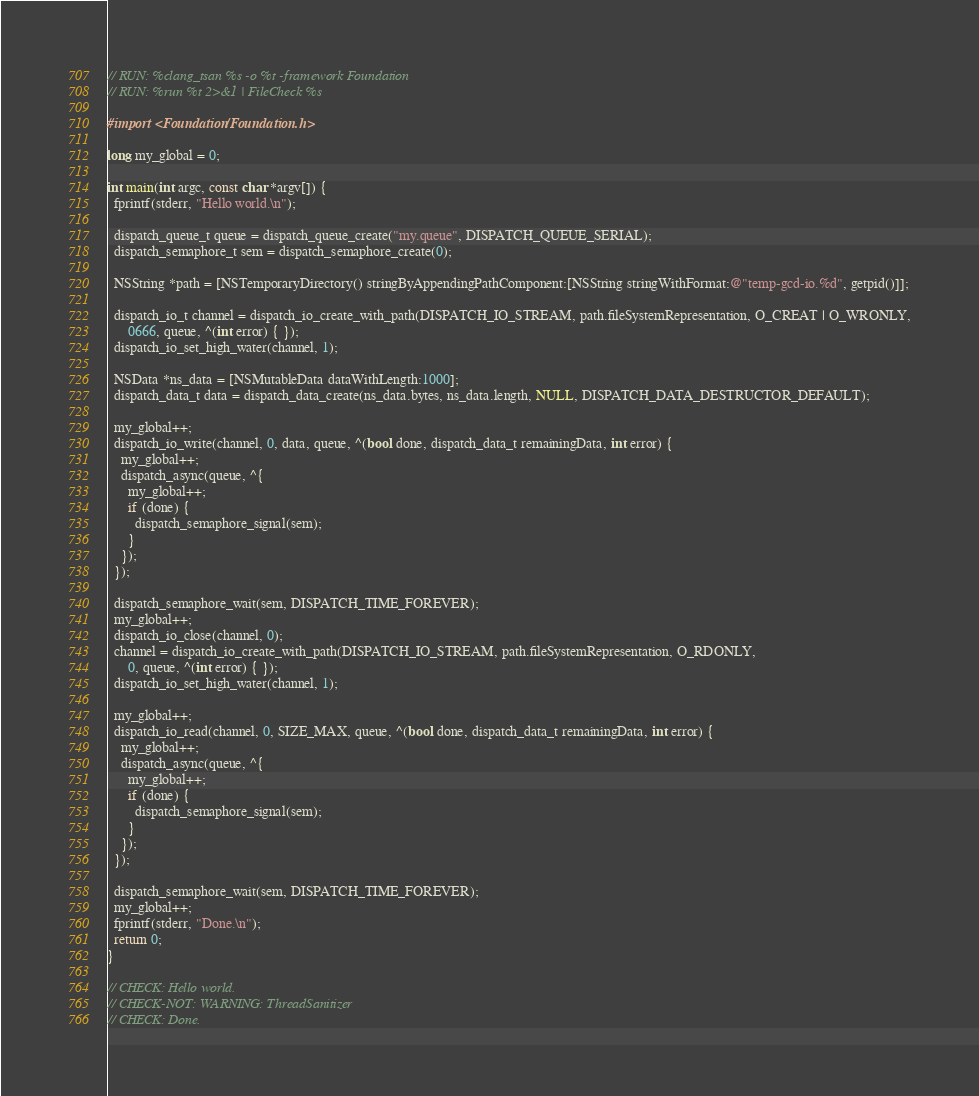<code> <loc_0><loc_0><loc_500><loc_500><_ObjectiveC_>// RUN: %clang_tsan %s -o %t -framework Foundation
// RUN: %run %t 2>&1 | FileCheck %s

#import <Foundation/Foundation.h>

long my_global = 0;

int main(int argc, const char *argv[]) {
  fprintf(stderr, "Hello world.\n");

  dispatch_queue_t queue = dispatch_queue_create("my.queue", DISPATCH_QUEUE_SERIAL);
  dispatch_semaphore_t sem = dispatch_semaphore_create(0);

  NSString *path = [NSTemporaryDirectory() stringByAppendingPathComponent:[NSString stringWithFormat:@"temp-gcd-io.%d", getpid()]];

  dispatch_io_t channel = dispatch_io_create_with_path(DISPATCH_IO_STREAM, path.fileSystemRepresentation, O_CREAT | O_WRONLY,
      0666, queue, ^(int error) { });
  dispatch_io_set_high_water(channel, 1);

  NSData *ns_data = [NSMutableData dataWithLength:1000];
  dispatch_data_t data = dispatch_data_create(ns_data.bytes, ns_data.length, NULL, DISPATCH_DATA_DESTRUCTOR_DEFAULT);

  my_global++;
  dispatch_io_write(channel, 0, data, queue, ^(bool done, dispatch_data_t remainingData, int error) {
    my_global++;
    dispatch_async(queue, ^{
      my_global++;
      if (done) {
        dispatch_semaphore_signal(sem);
      }
    });
  });

  dispatch_semaphore_wait(sem, DISPATCH_TIME_FOREVER);
  my_global++;
  dispatch_io_close(channel, 0);
  channel = dispatch_io_create_with_path(DISPATCH_IO_STREAM, path.fileSystemRepresentation, O_RDONLY,
      0, queue, ^(int error) { });
  dispatch_io_set_high_water(channel, 1);

  my_global++;
  dispatch_io_read(channel, 0, SIZE_MAX, queue, ^(bool done, dispatch_data_t remainingData, int error) {
    my_global++;
    dispatch_async(queue, ^{
      my_global++;
      if (done) {
        dispatch_semaphore_signal(sem);
      }
    });
  });

  dispatch_semaphore_wait(sem, DISPATCH_TIME_FOREVER);
  my_global++;
  fprintf(stderr, "Done.\n");
  return 0;
}

// CHECK: Hello world.
// CHECK-NOT: WARNING: ThreadSanitizer
// CHECK: Done.
</code> 